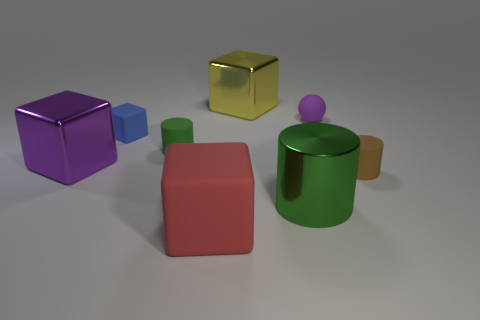What is the color of the smallest object in the image? The smallest object in the image is a small blue cube. Its color stands out among the other, larger shapes surrounding it. 